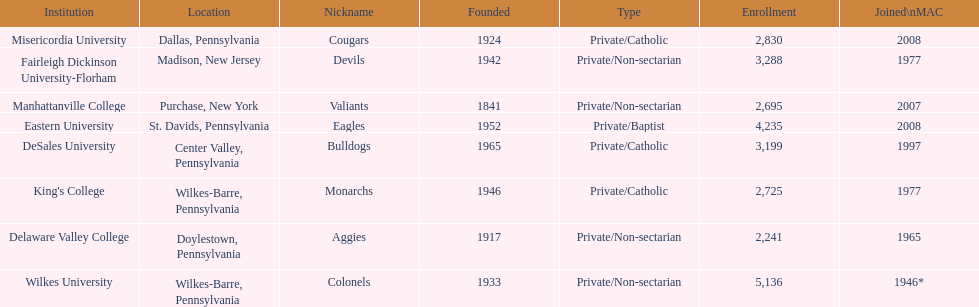How many are enrolled in private/catholic? 8,754. 